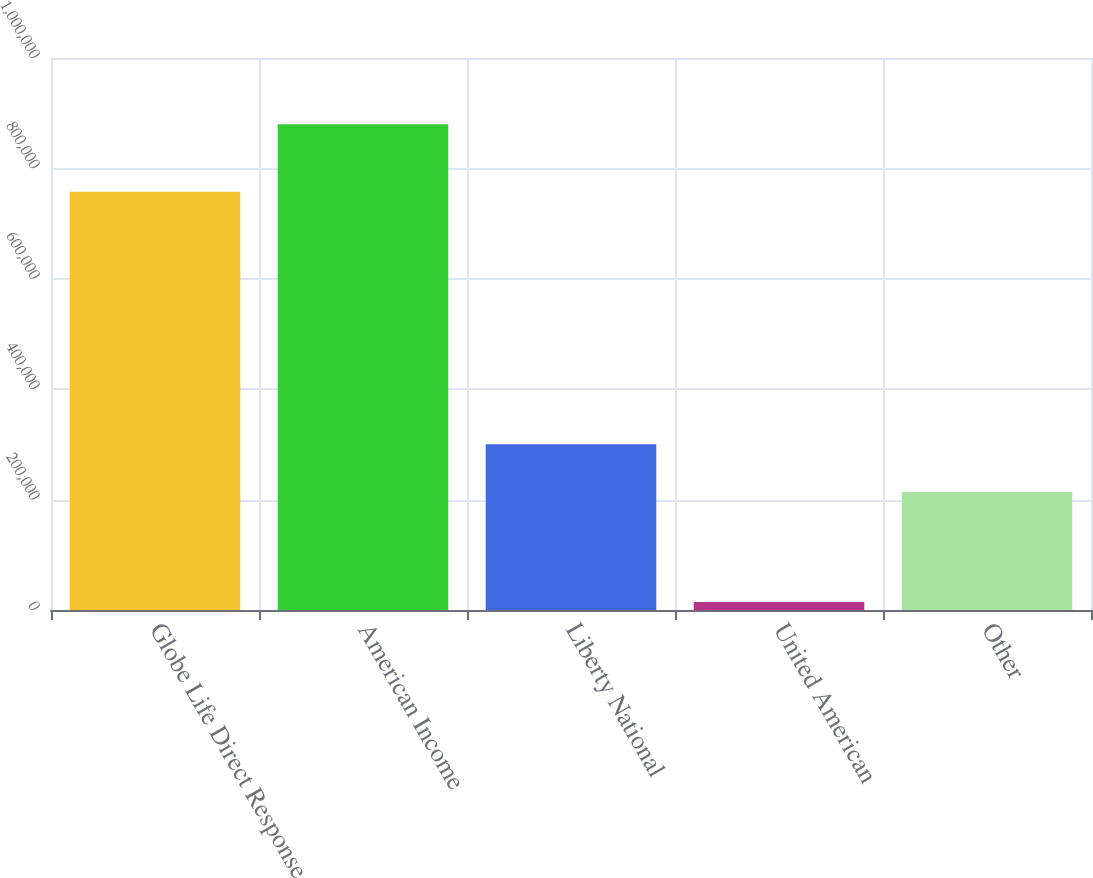Convert chart to OTSL. <chart><loc_0><loc_0><loc_500><loc_500><bar_chart><fcel>Globe Life Direct Response<fcel>American Income<fcel>Liberty National<fcel>United American<fcel>Other<nl><fcel>757518<fcel>880021<fcel>300427<fcel>14488<fcel>213874<nl></chart> 